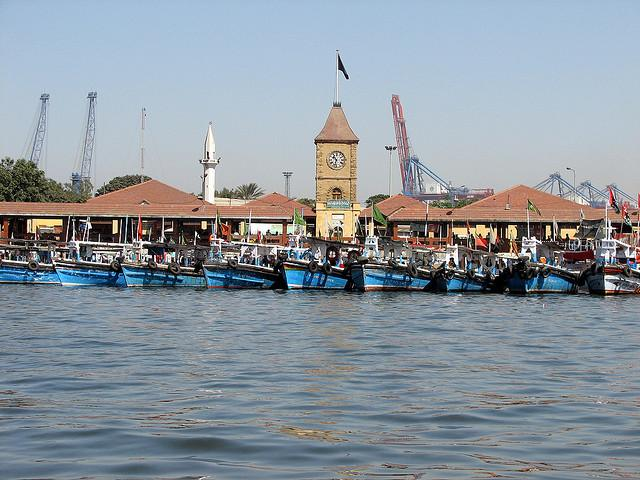What except for a flag are the highest emanations coming from here? Please explain your reasoning. cranes. There are several tall cranes in the background that are higher than everything else. 